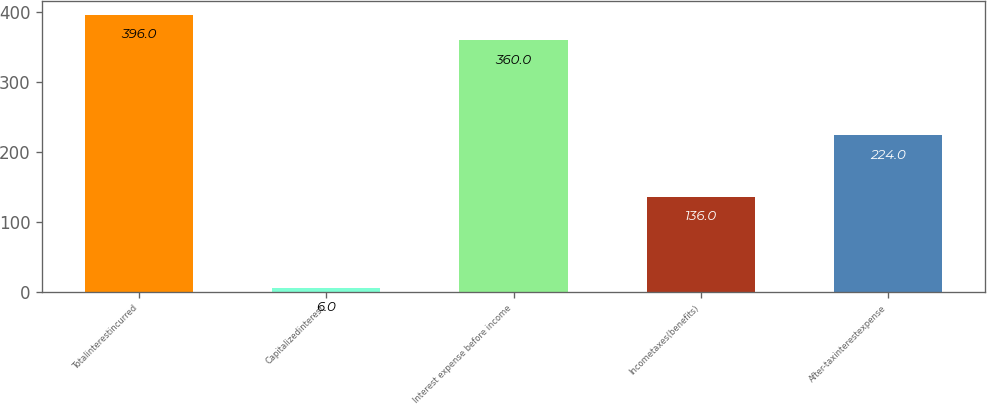Convert chart. <chart><loc_0><loc_0><loc_500><loc_500><bar_chart><fcel>Totalinterestincurred<fcel>Capitalizedinterest<fcel>Interest expense before income<fcel>Incometaxes(benefits)<fcel>After-taxinterestexpense<nl><fcel>396<fcel>6<fcel>360<fcel>136<fcel>224<nl></chart> 